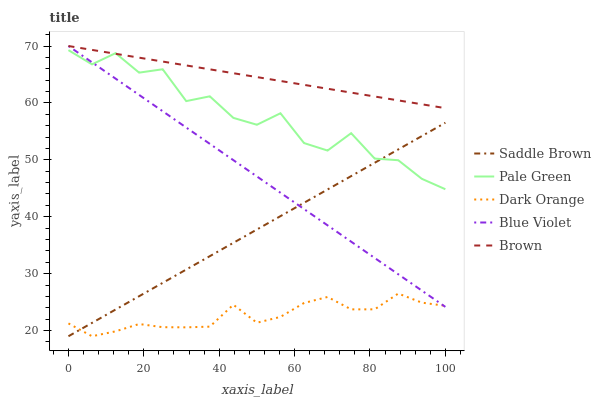Does Pale Green have the minimum area under the curve?
Answer yes or no. No. Does Pale Green have the maximum area under the curve?
Answer yes or no. No. Is Saddle Brown the smoothest?
Answer yes or no. No. Is Saddle Brown the roughest?
Answer yes or no. No. Does Pale Green have the lowest value?
Answer yes or no. No. Does Pale Green have the highest value?
Answer yes or no. No. Is Dark Orange less than Pale Green?
Answer yes or no. Yes. Is Pale Green greater than Dark Orange?
Answer yes or no. Yes. Does Dark Orange intersect Pale Green?
Answer yes or no. No. 